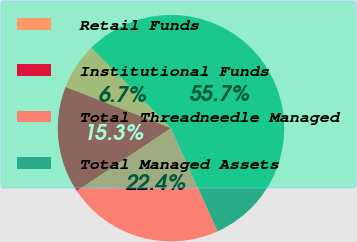<chart> <loc_0><loc_0><loc_500><loc_500><pie_chart><fcel>Retail Funds<fcel>Institutional Funds<fcel>Total Threadneedle Managed<fcel>Total Managed Assets<nl><fcel>6.66%<fcel>15.29%<fcel>22.38%<fcel>55.66%<nl></chart> 